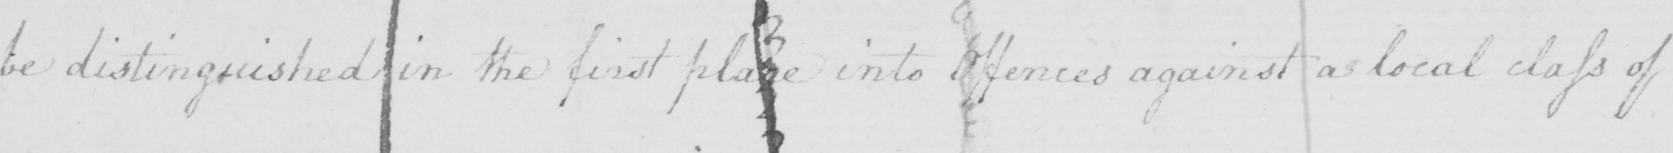What is written in this line of handwriting? be distinguished in the first place into offences against a local class of 